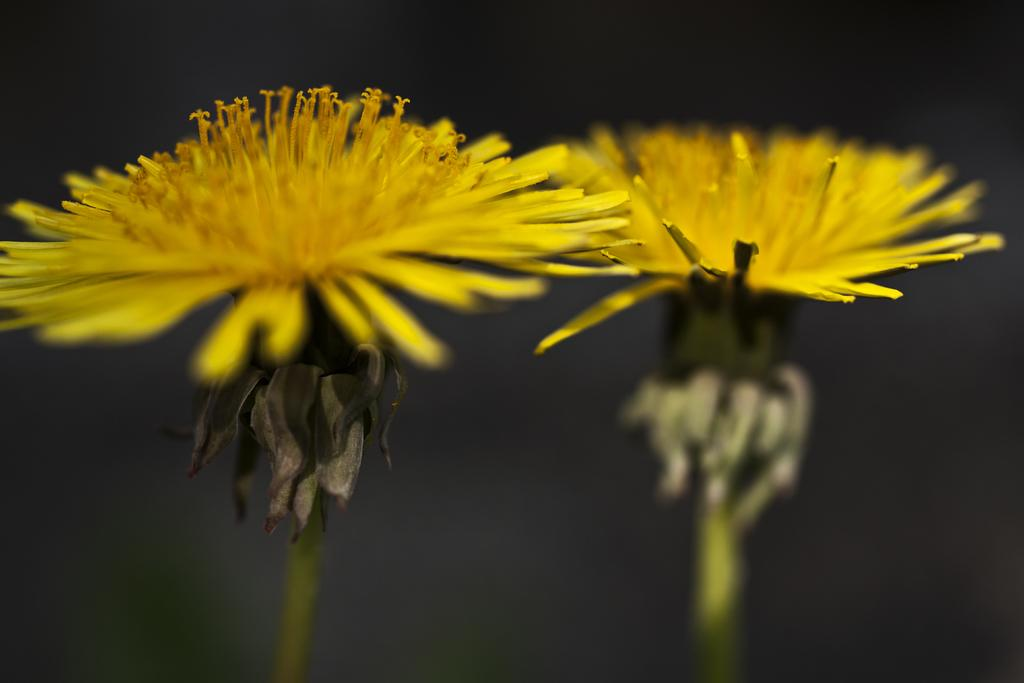What type of flowers can be seen in the image? There are two yellow flowers in the image. What color is the background of the image? The background of the image is black. What type of star can be seen in the image? There is no star present in the image; it features two yellow flowers against a black background. What type of meal is being prepared in the image? There is no meal preparation visible in the image; it only contains two yellow flowers and a black background. 